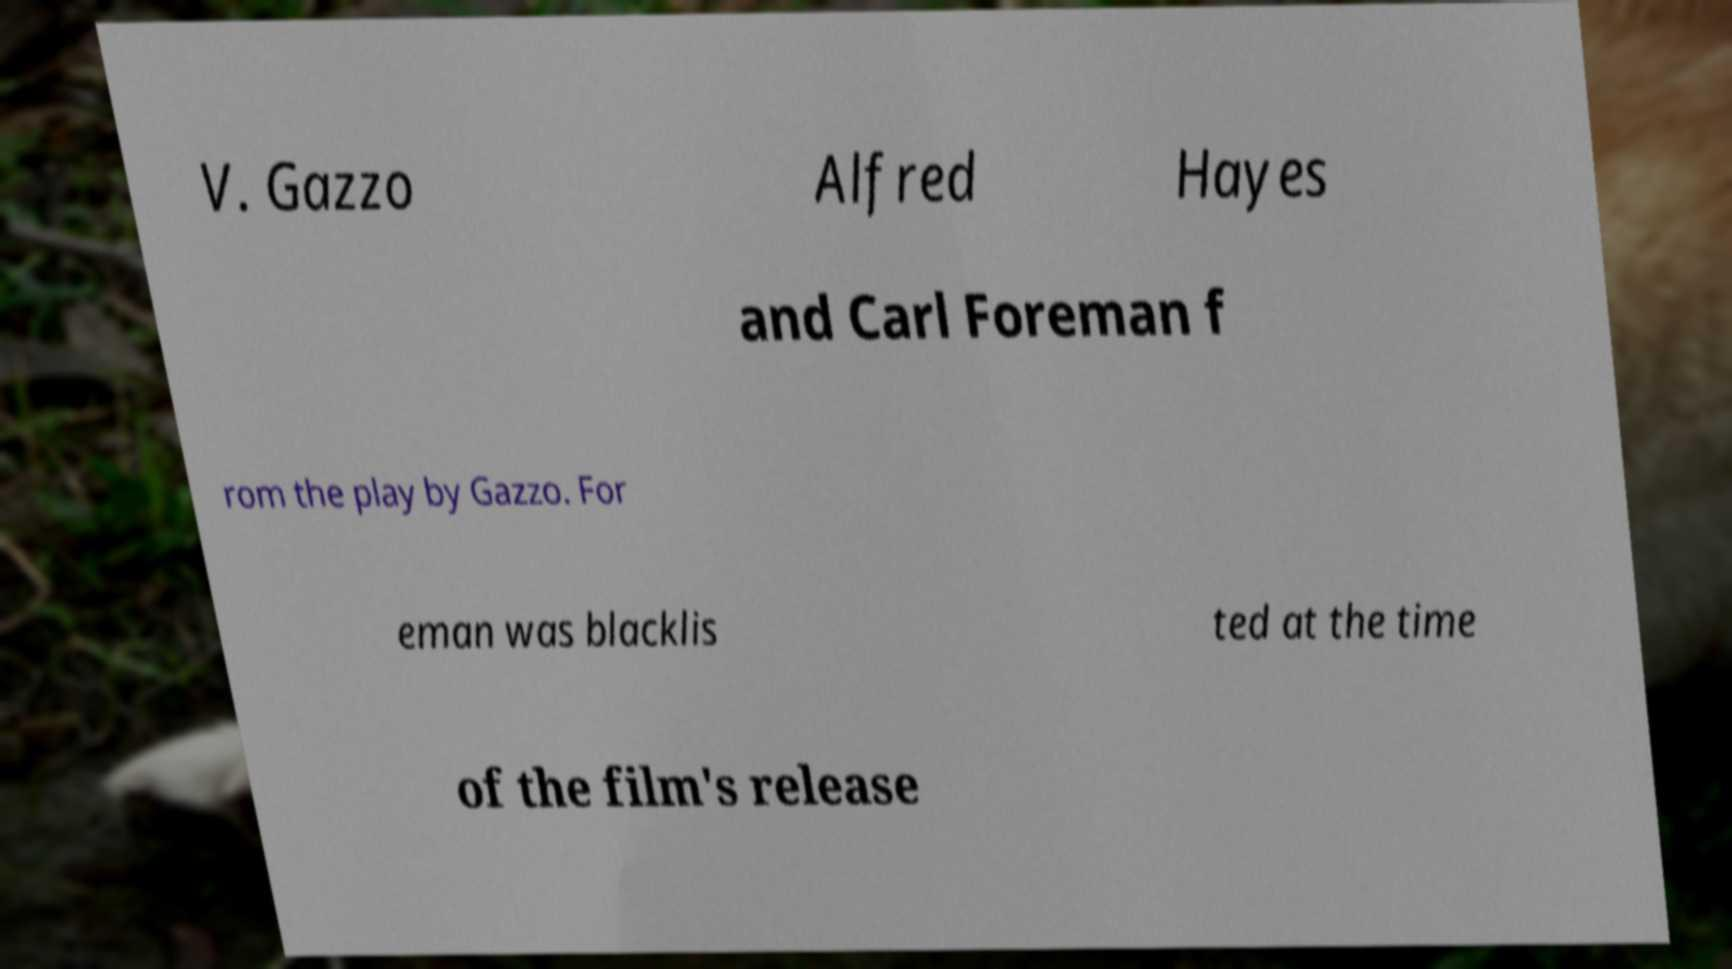Could you assist in decoding the text presented in this image and type it out clearly? V. Gazzo Alfred Hayes and Carl Foreman f rom the play by Gazzo. For eman was blacklis ted at the time of the film's release 